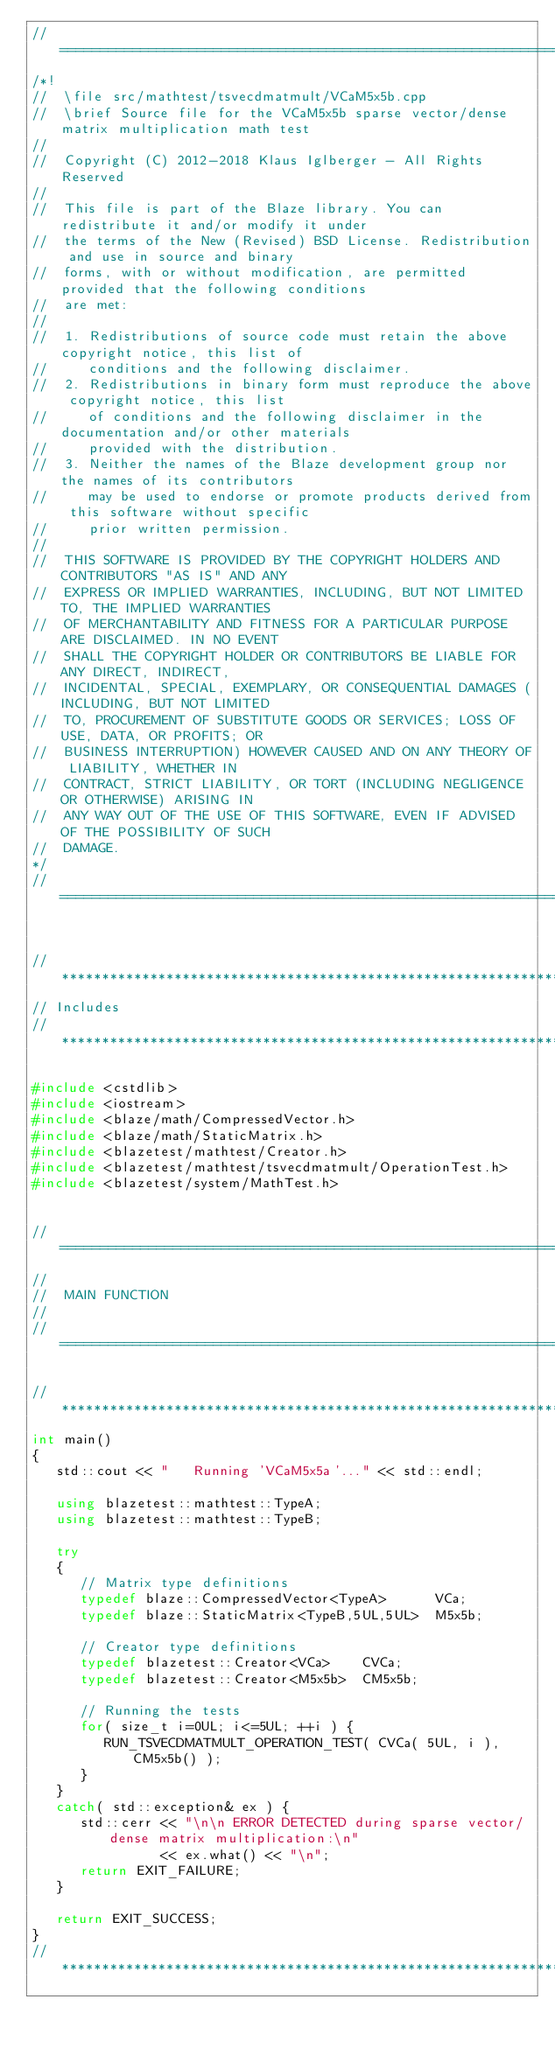<code> <loc_0><loc_0><loc_500><loc_500><_C++_>//=================================================================================================
/*!
//  \file src/mathtest/tsvecdmatmult/VCaM5x5b.cpp
//  \brief Source file for the VCaM5x5b sparse vector/dense matrix multiplication math test
//
//  Copyright (C) 2012-2018 Klaus Iglberger - All Rights Reserved
//
//  This file is part of the Blaze library. You can redistribute it and/or modify it under
//  the terms of the New (Revised) BSD License. Redistribution and use in source and binary
//  forms, with or without modification, are permitted provided that the following conditions
//  are met:
//
//  1. Redistributions of source code must retain the above copyright notice, this list of
//     conditions and the following disclaimer.
//  2. Redistributions in binary form must reproduce the above copyright notice, this list
//     of conditions and the following disclaimer in the documentation and/or other materials
//     provided with the distribution.
//  3. Neither the names of the Blaze development group nor the names of its contributors
//     may be used to endorse or promote products derived from this software without specific
//     prior written permission.
//
//  THIS SOFTWARE IS PROVIDED BY THE COPYRIGHT HOLDERS AND CONTRIBUTORS "AS IS" AND ANY
//  EXPRESS OR IMPLIED WARRANTIES, INCLUDING, BUT NOT LIMITED TO, THE IMPLIED WARRANTIES
//  OF MERCHANTABILITY AND FITNESS FOR A PARTICULAR PURPOSE ARE DISCLAIMED. IN NO EVENT
//  SHALL THE COPYRIGHT HOLDER OR CONTRIBUTORS BE LIABLE FOR ANY DIRECT, INDIRECT,
//  INCIDENTAL, SPECIAL, EXEMPLARY, OR CONSEQUENTIAL DAMAGES (INCLUDING, BUT NOT LIMITED
//  TO, PROCUREMENT OF SUBSTITUTE GOODS OR SERVICES; LOSS OF USE, DATA, OR PROFITS; OR
//  BUSINESS INTERRUPTION) HOWEVER CAUSED AND ON ANY THEORY OF LIABILITY, WHETHER IN
//  CONTRACT, STRICT LIABILITY, OR TORT (INCLUDING NEGLIGENCE OR OTHERWISE) ARISING IN
//  ANY WAY OUT OF THE USE OF THIS SOFTWARE, EVEN IF ADVISED OF THE POSSIBILITY OF SUCH
//  DAMAGE.
*/
//=================================================================================================


//*************************************************************************************************
// Includes
//*************************************************************************************************

#include <cstdlib>
#include <iostream>
#include <blaze/math/CompressedVector.h>
#include <blaze/math/StaticMatrix.h>
#include <blazetest/mathtest/Creator.h>
#include <blazetest/mathtest/tsvecdmatmult/OperationTest.h>
#include <blazetest/system/MathTest.h>


//=================================================================================================
//
//  MAIN FUNCTION
//
//=================================================================================================

//*************************************************************************************************
int main()
{
   std::cout << "   Running 'VCaM5x5a'..." << std::endl;

   using blazetest::mathtest::TypeA;
   using blazetest::mathtest::TypeB;

   try
   {
      // Matrix type definitions
      typedef blaze::CompressedVector<TypeA>      VCa;
      typedef blaze::StaticMatrix<TypeB,5UL,5UL>  M5x5b;

      // Creator type definitions
      typedef blazetest::Creator<VCa>    CVCa;
      typedef blazetest::Creator<M5x5b>  CM5x5b;

      // Running the tests
      for( size_t i=0UL; i<=5UL; ++i ) {
         RUN_TSVECDMATMULT_OPERATION_TEST( CVCa( 5UL, i ), CM5x5b() );
      }
   }
   catch( std::exception& ex ) {
      std::cerr << "\n\n ERROR DETECTED during sparse vector/dense matrix multiplication:\n"
                << ex.what() << "\n";
      return EXIT_FAILURE;
   }

   return EXIT_SUCCESS;
}
//*************************************************************************************************
</code> 